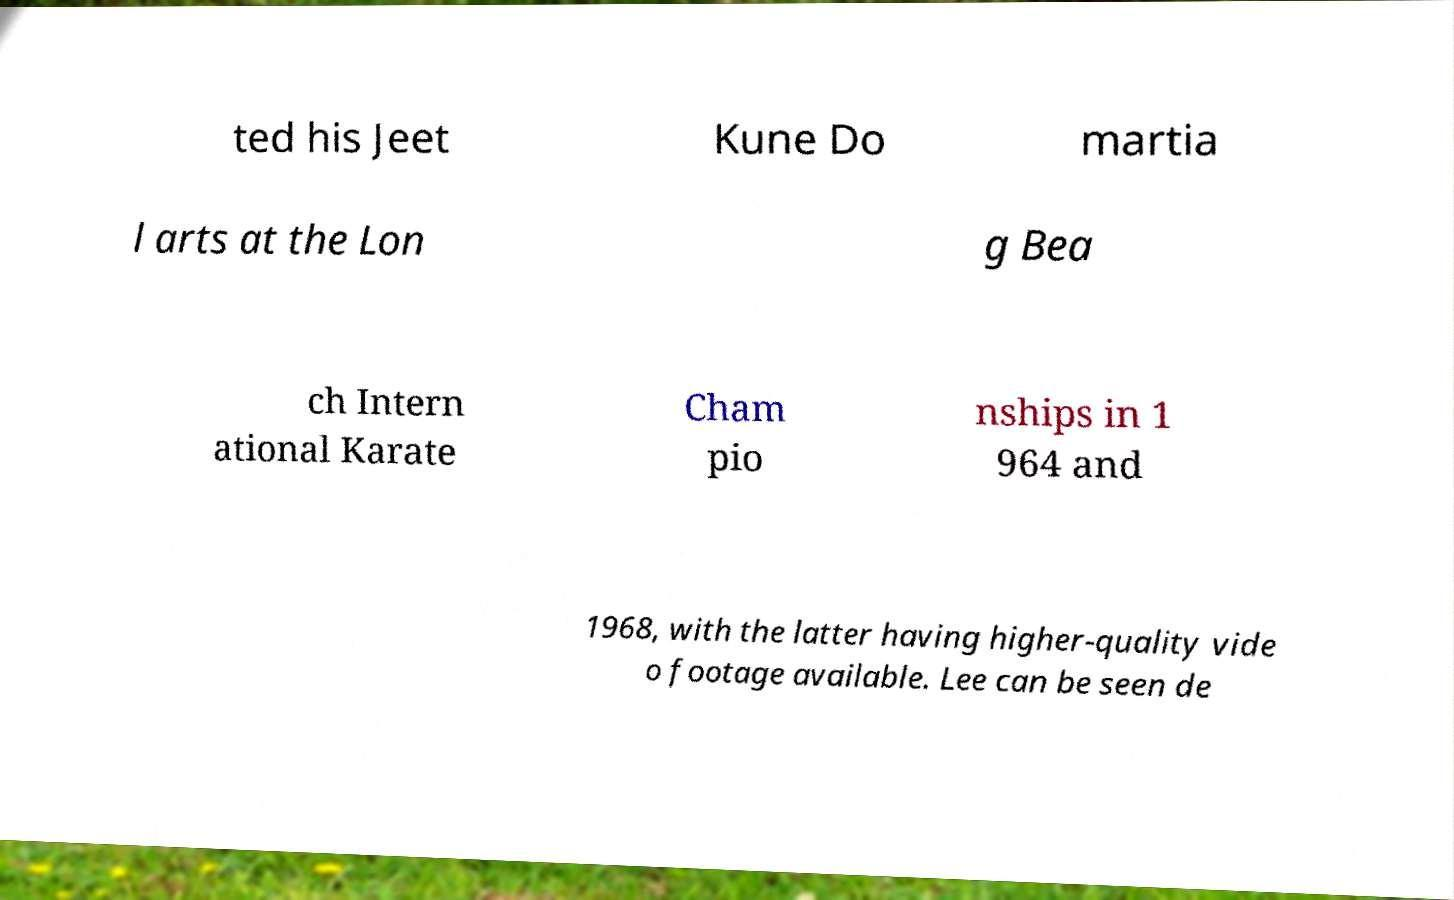For documentation purposes, I need the text within this image transcribed. Could you provide that? ted his Jeet Kune Do martia l arts at the Lon g Bea ch Intern ational Karate Cham pio nships in 1 964 and 1968, with the latter having higher-quality vide o footage available. Lee can be seen de 